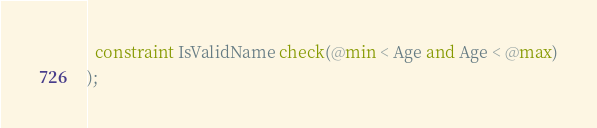<code> <loc_0><loc_0><loc_500><loc_500><_SQL_>  constraint IsValidName check(@min < Age and Age < @max)
);
</code> 